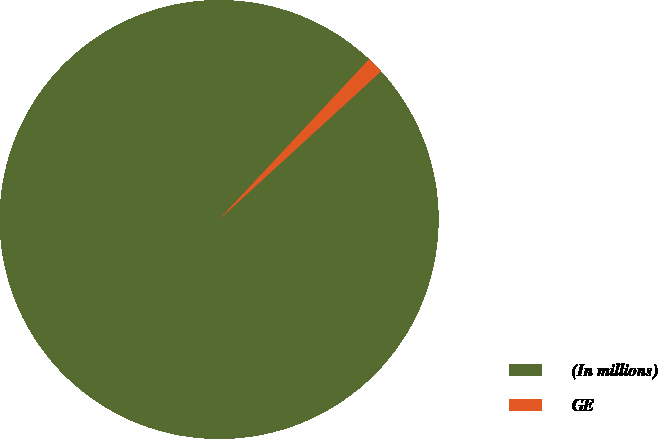Convert chart. <chart><loc_0><loc_0><loc_500><loc_500><pie_chart><fcel>(In millions)<fcel>GE<nl><fcel>98.77%<fcel>1.23%<nl></chart> 